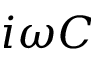Convert formula to latex. <formula><loc_0><loc_0><loc_500><loc_500>i \omega C</formula> 